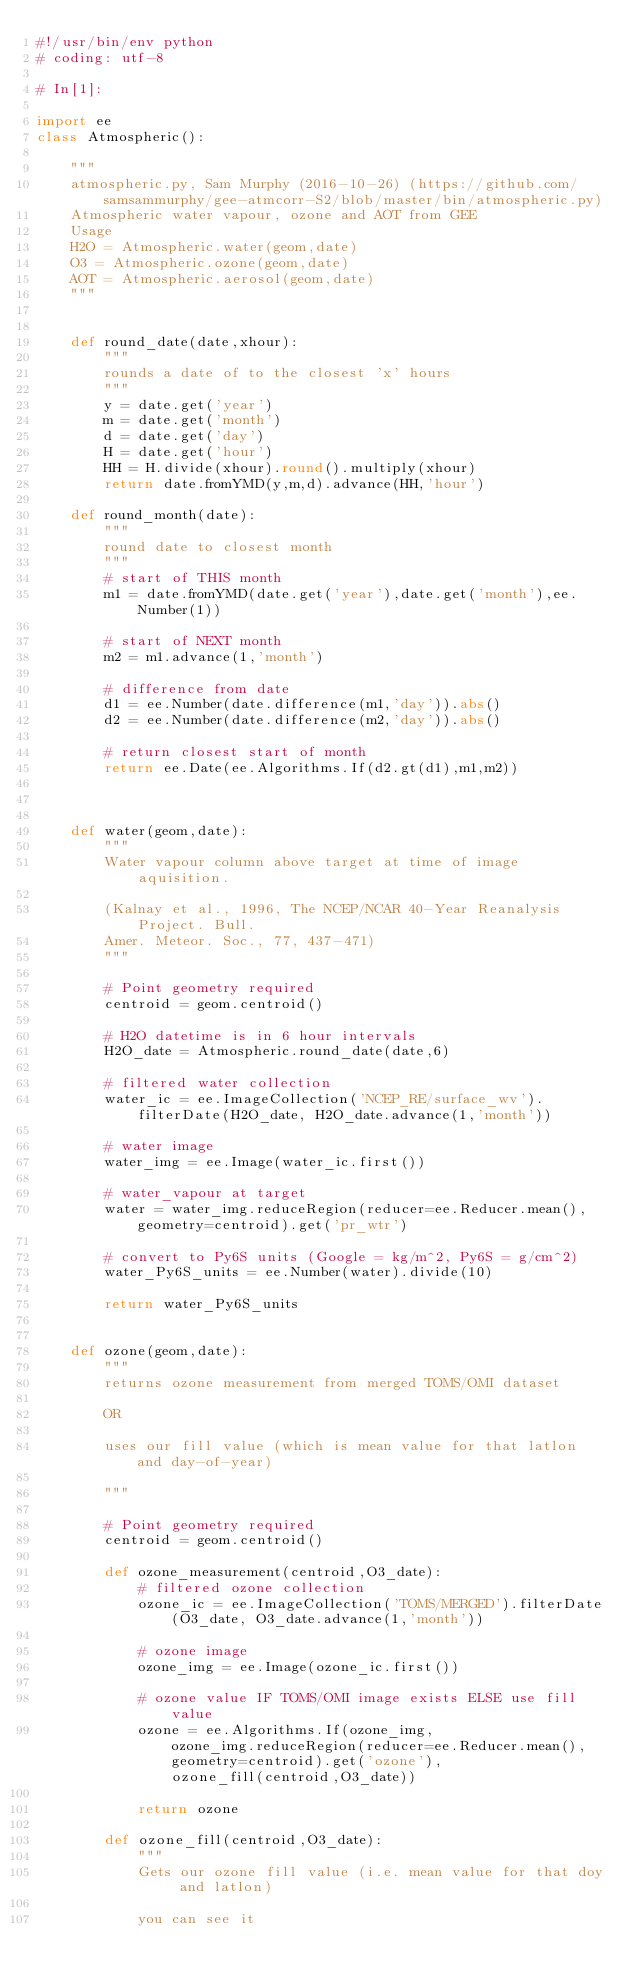<code> <loc_0><loc_0><loc_500><loc_500><_Python_>#!/usr/bin/env python
# coding: utf-8

# In[1]:

import ee
class Atmospheric():
    
    """
    atmospheric.py, Sam Murphy (2016-10-26) (https://github.com/samsammurphy/gee-atmcorr-S2/blob/master/bin/atmospheric.py)
    Atmospheric water vapour, ozone and AOT from GEE
    Usage
    H2O = Atmospheric.water(geom,date)
    O3 = Atmospheric.ozone(geom,date)
    AOT = Atmospheric.aerosol(geom,date)
    """

    
    def round_date(date,xhour):
        """
        rounds a date of to the closest 'x' hours
        """
        y = date.get('year')
        m = date.get('month')
        d = date.get('day')
        H = date.get('hour')
        HH = H.divide(xhour).round().multiply(xhour)
        return date.fromYMD(y,m,d).advance(HH,'hour')
  
    def round_month(date):
        """
        round date to closest month
        """
        # start of THIS month
        m1 = date.fromYMD(date.get('year'),date.get('month'),ee.Number(1))

        # start of NEXT month
        m2 = m1.advance(1,'month')

        # difference from date
        d1 = ee.Number(date.difference(m1,'day')).abs()
        d2 = ee.Number(date.difference(m2,'day')).abs()

        # return closest start of month
        return ee.Date(ee.Algorithms.If(d2.gt(d1),m1,m2))



    def water(geom,date):
        """
        Water vapour column above target at time of image aquisition.

        (Kalnay et al., 1996, The NCEP/NCAR 40-Year Reanalysis Project. Bull. 
        Amer. Meteor. Soc., 77, 437-471)
        """

        # Point geometry required
        centroid = geom.centroid()

        # H2O datetime is in 6 hour intervals
        H2O_date = Atmospheric.round_date(date,6)

        # filtered water collection
        water_ic = ee.ImageCollection('NCEP_RE/surface_wv').filterDate(H2O_date, H2O_date.advance(1,'month'))

        # water image
        water_img = ee.Image(water_ic.first())

        # water_vapour at target
        water = water_img.reduceRegion(reducer=ee.Reducer.mean(), geometry=centroid).get('pr_wtr')

        # convert to Py6S units (Google = kg/m^2, Py6S = g/cm^2)
        water_Py6S_units = ee.Number(water).divide(10)                                   

        return water_Py6S_units


    def ozone(geom,date):
        """
        returns ozone measurement from merged TOMS/OMI dataset

        OR

        uses our fill value (which is mean value for that latlon and day-of-year)

        """

        # Point geometry required
        centroid = geom.centroid()

        def ozone_measurement(centroid,O3_date):
            # filtered ozone collection
            ozone_ic = ee.ImageCollection('TOMS/MERGED').filterDate(O3_date, O3_date.advance(1,'month'))

            # ozone image
            ozone_img = ee.Image(ozone_ic.first())

            # ozone value IF TOMS/OMI image exists ELSE use fill value
            ozone = ee.Algorithms.If(ozone_img,            ozone_img.reduceRegion(reducer=ee.Reducer.mean(), geometry=centroid).get('ozone'),            ozone_fill(centroid,O3_date))

            return ozone

        def ozone_fill(centroid,O3_date):
            """
            Gets our ozone fill value (i.e. mean value for that doy and latlon)

            you can see it</code> 